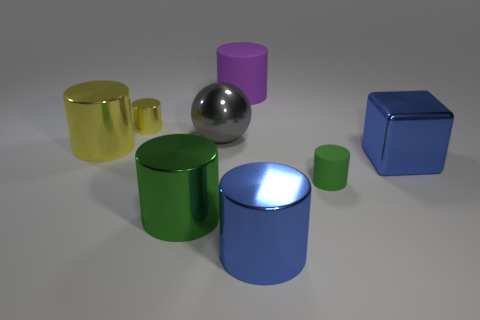Do the small shiny cylinder and the matte cylinder that is in front of the big shiny block have the same color?
Your answer should be very brief. No. What is the shape of the object that is behind the big gray thing and to the right of the tiny yellow object?
Your response must be concise. Cylinder. What number of small green things are there?
Keep it short and to the point. 1. There is another yellow metal object that is the same shape as the tiny yellow metallic thing; what size is it?
Offer a very short reply. Large. Does the blue shiny thing in front of the green metallic cylinder have the same shape as the large purple rubber object?
Offer a terse response. Yes. There is a tiny object that is on the right side of the large purple matte cylinder; what color is it?
Offer a very short reply. Green. How many other things are there of the same size as the purple object?
Give a very brief answer. 5. Are there any other things that have the same shape as the small green rubber thing?
Provide a short and direct response. Yes. Is the number of cylinders that are to the right of the big yellow shiny cylinder the same as the number of green shiny objects?
Make the answer very short. No. What number of tiny brown cylinders are the same material as the large yellow cylinder?
Your response must be concise. 0. 